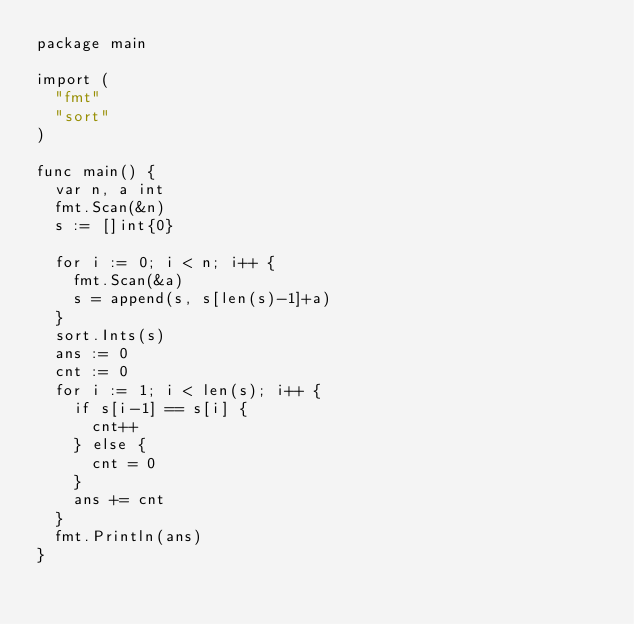<code> <loc_0><loc_0><loc_500><loc_500><_Go_>package main

import (
	"fmt"
	"sort"
)

func main() {
	var n, a int
	fmt.Scan(&n)
	s := []int{0}

	for i := 0; i < n; i++ {
		fmt.Scan(&a)
		s = append(s, s[len(s)-1]+a)
	}
	sort.Ints(s)
	ans := 0
	cnt := 0
	for i := 1; i < len(s); i++ {
		if s[i-1] == s[i] {
			cnt++
		} else {
			cnt = 0
		}
		ans += cnt
	}
	fmt.Println(ans)
}
</code> 